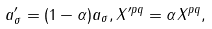Convert formula to latex. <formula><loc_0><loc_0><loc_500><loc_500>a _ { \sigma } ^ { \prime } = ( 1 - \alpha ) a _ { \sigma } , X ^ { \prime p q } = \alpha X ^ { p q } ,</formula> 